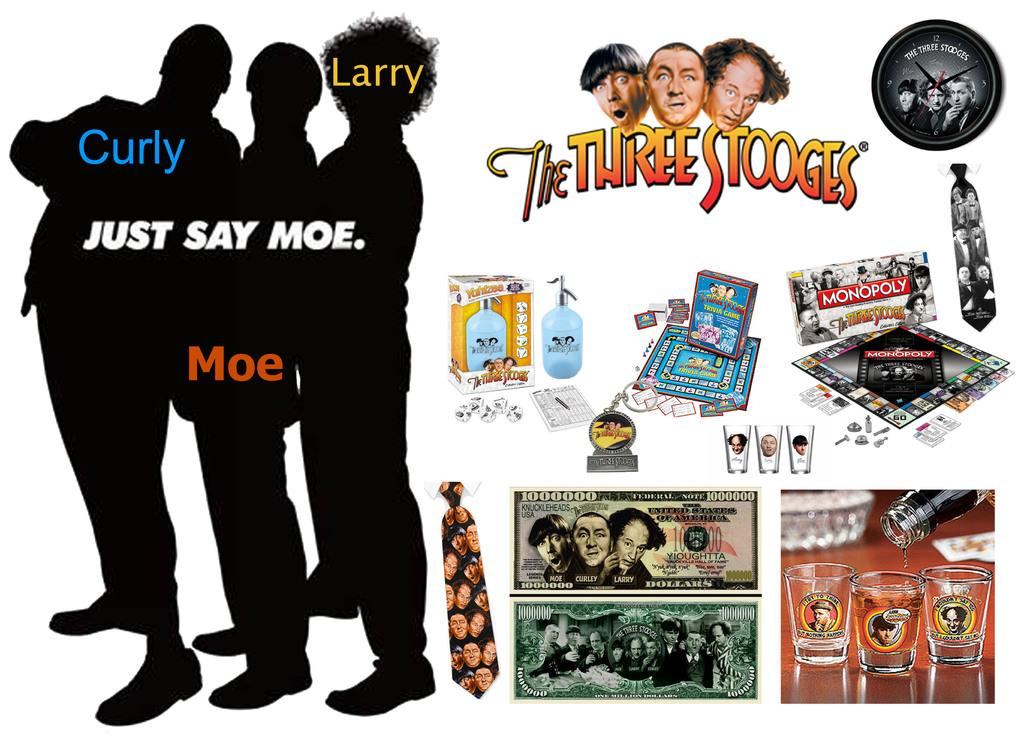<image>
Give a short and clear explanation of the subsequent image. A Three Stooges Collectibles Memorbillia Display with various souveneirs 